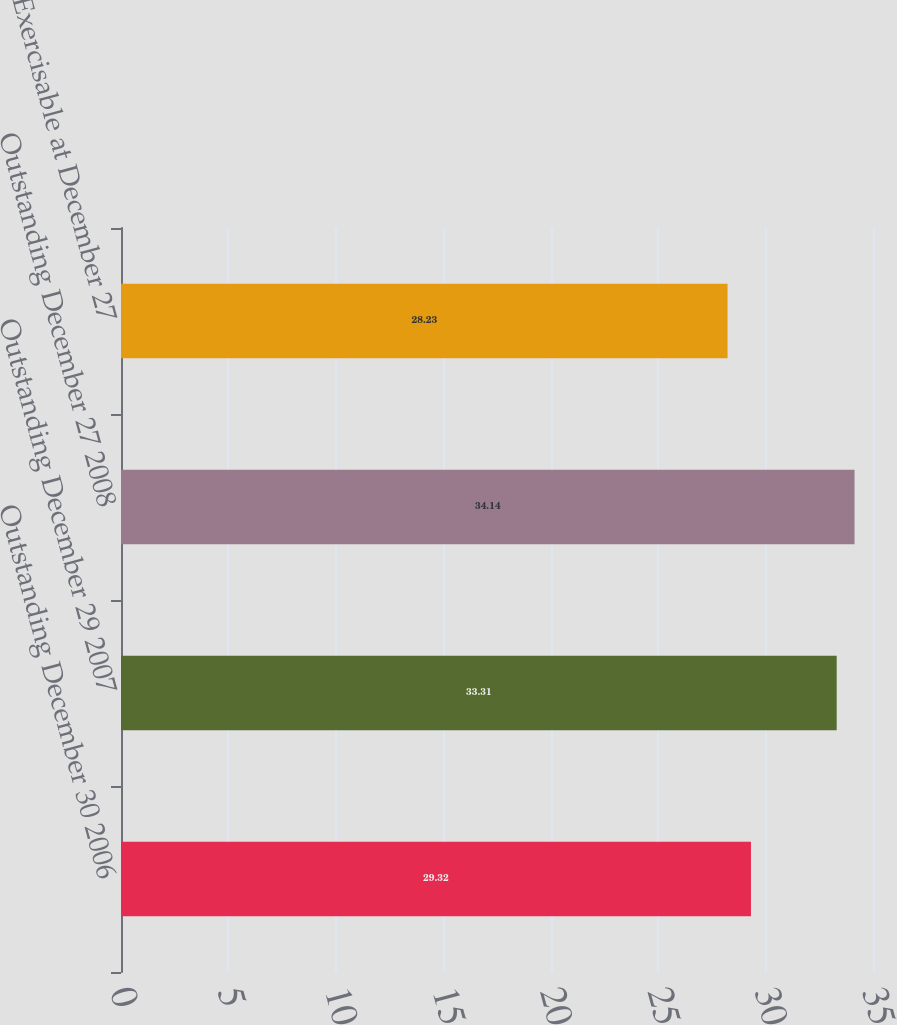Convert chart. <chart><loc_0><loc_0><loc_500><loc_500><bar_chart><fcel>Outstanding December 30 2006<fcel>Outstanding December 29 2007<fcel>Outstanding December 27 2008<fcel>Exercisable at December 27<nl><fcel>29.32<fcel>33.31<fcel>34.14<fcel>28.23<nl></chart> 